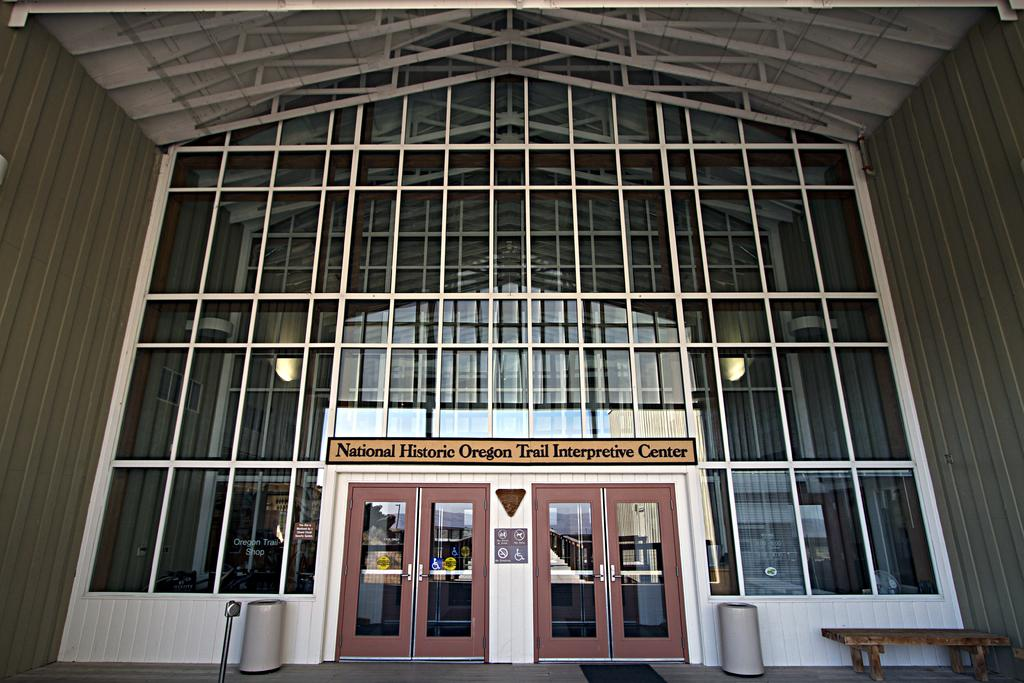What type of architectural feature can be seen in the image? There are doors in the image. What piece of furniture is present in the image? There is a table in the image. What is on the floor in the image? There are objects on the floor in the image. What type of wall is present in the image? There is a framed glass wall in the image. What type of illumination is present in the image? There are lights in the image. What other objects can be seen in the image? There are other objects in the image. What type of mouth can be seen on the objects in the image? There are no mouths present on the objects in the image. How does the fog affect the visibility in the image? There is no fog present in the image, so it does not affect the visibility. 